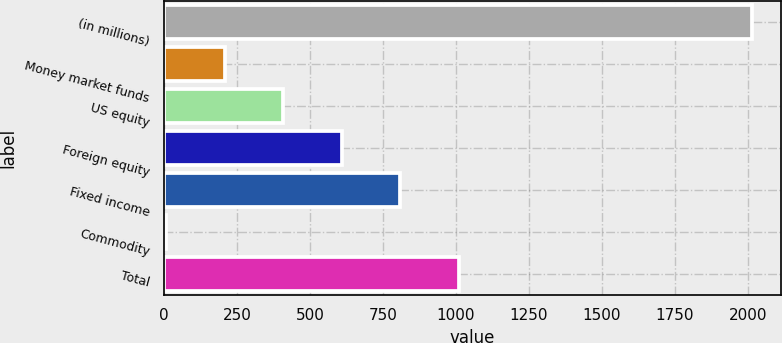Convert chart. <chart><loc_0><loc_0><loc_500><loc_500><bar_chart><fcel>(in millions)<fcel>Money market funds<fcel>US equity<fcel>Foreign equity<fcel>Fixed income<fcel>Commodity<fcel>Total<nl><fcel>2012<fcel>207.68<fcel>408.16<fcel>608.64<fcel>809.12<fcel>7.2<fcel>1009.6<nl></chart> 